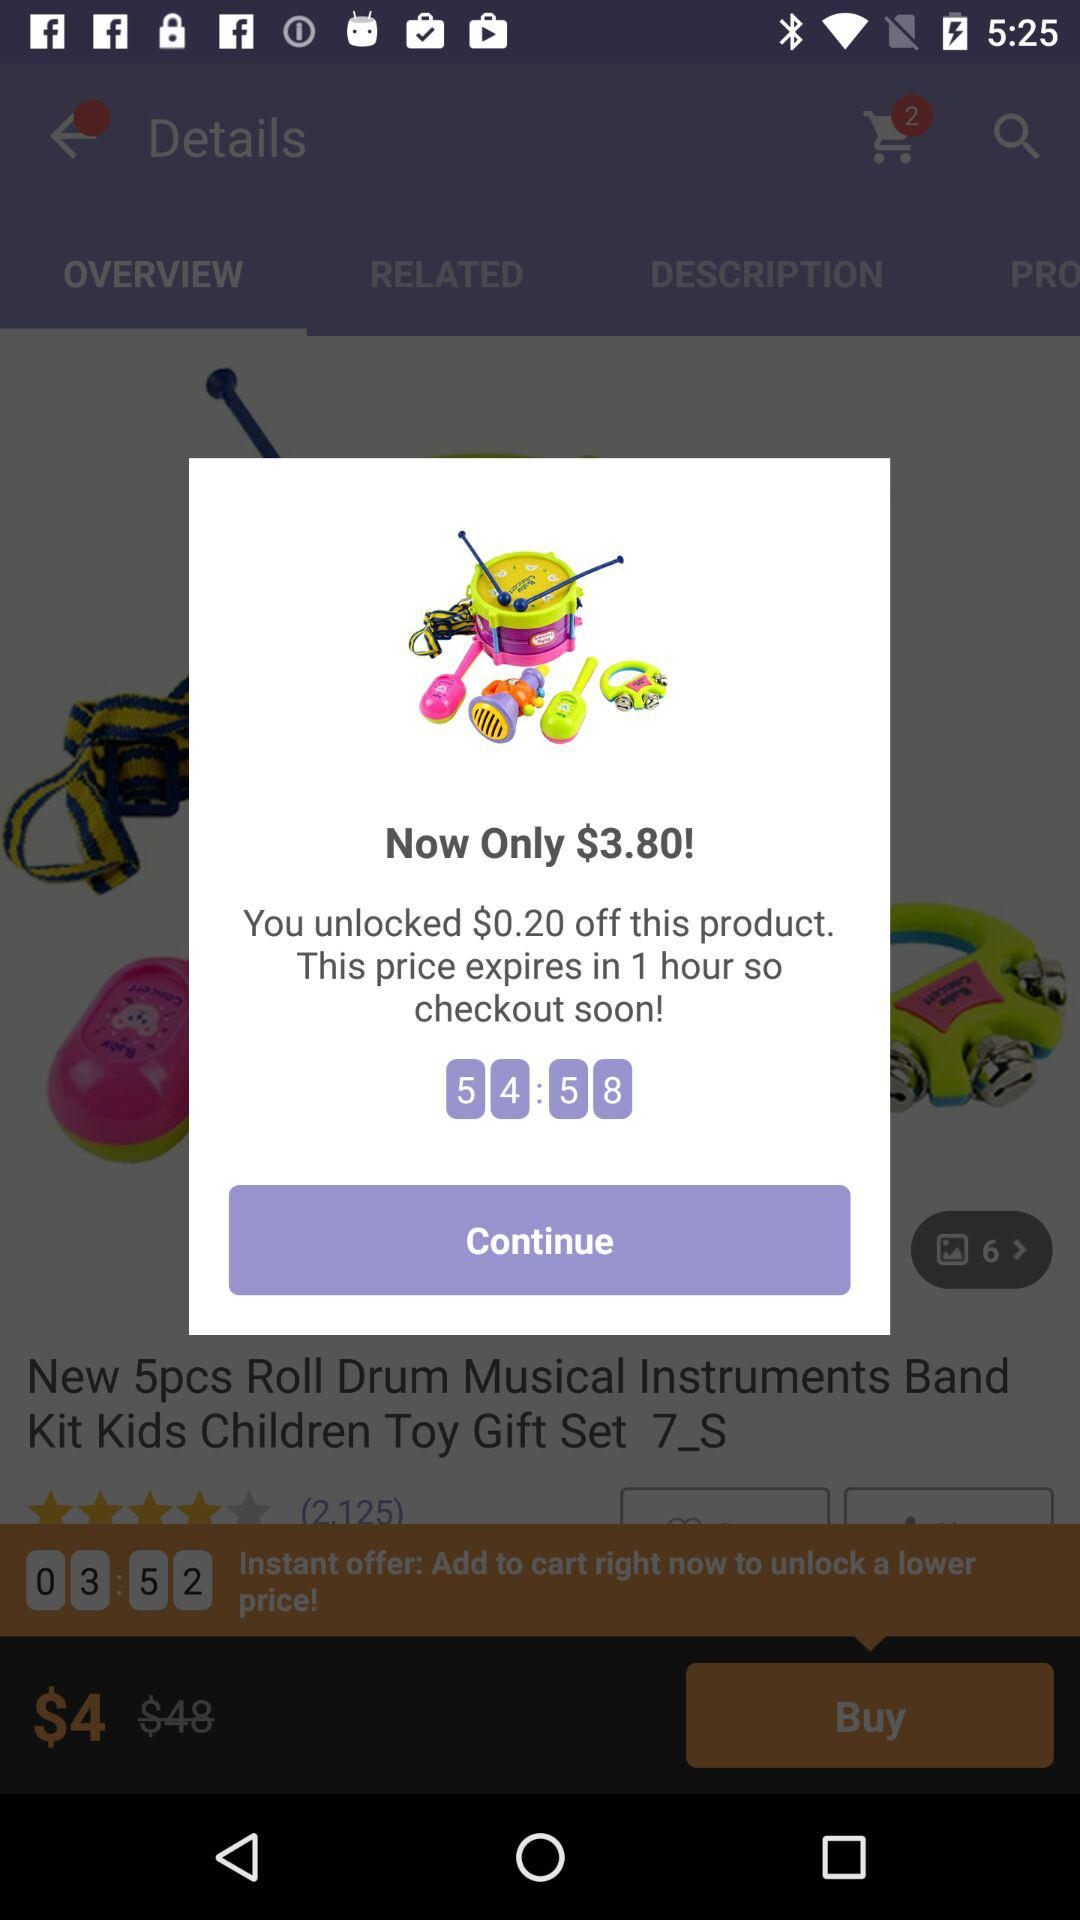What is the number of items in the shopping cart? The number of items is 2. 